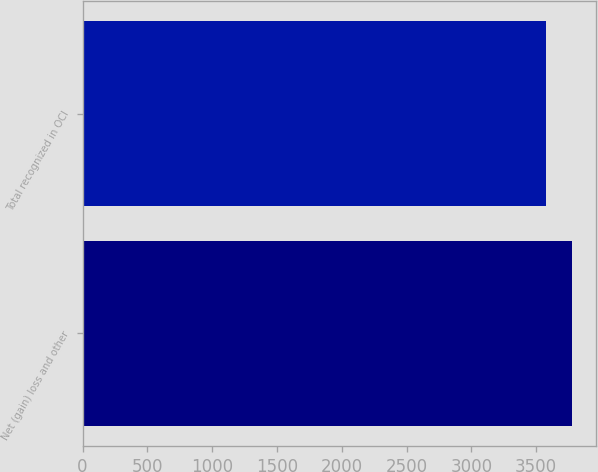Convert chart to OTSL. <chart><loc_0><loc_0><loc_500><loc_500><bar_chart><fcel>Net (gain) loss and other<fcel>Total recognized in OCI<nl><fcel>3777<fcel>3579<nl></chart> 